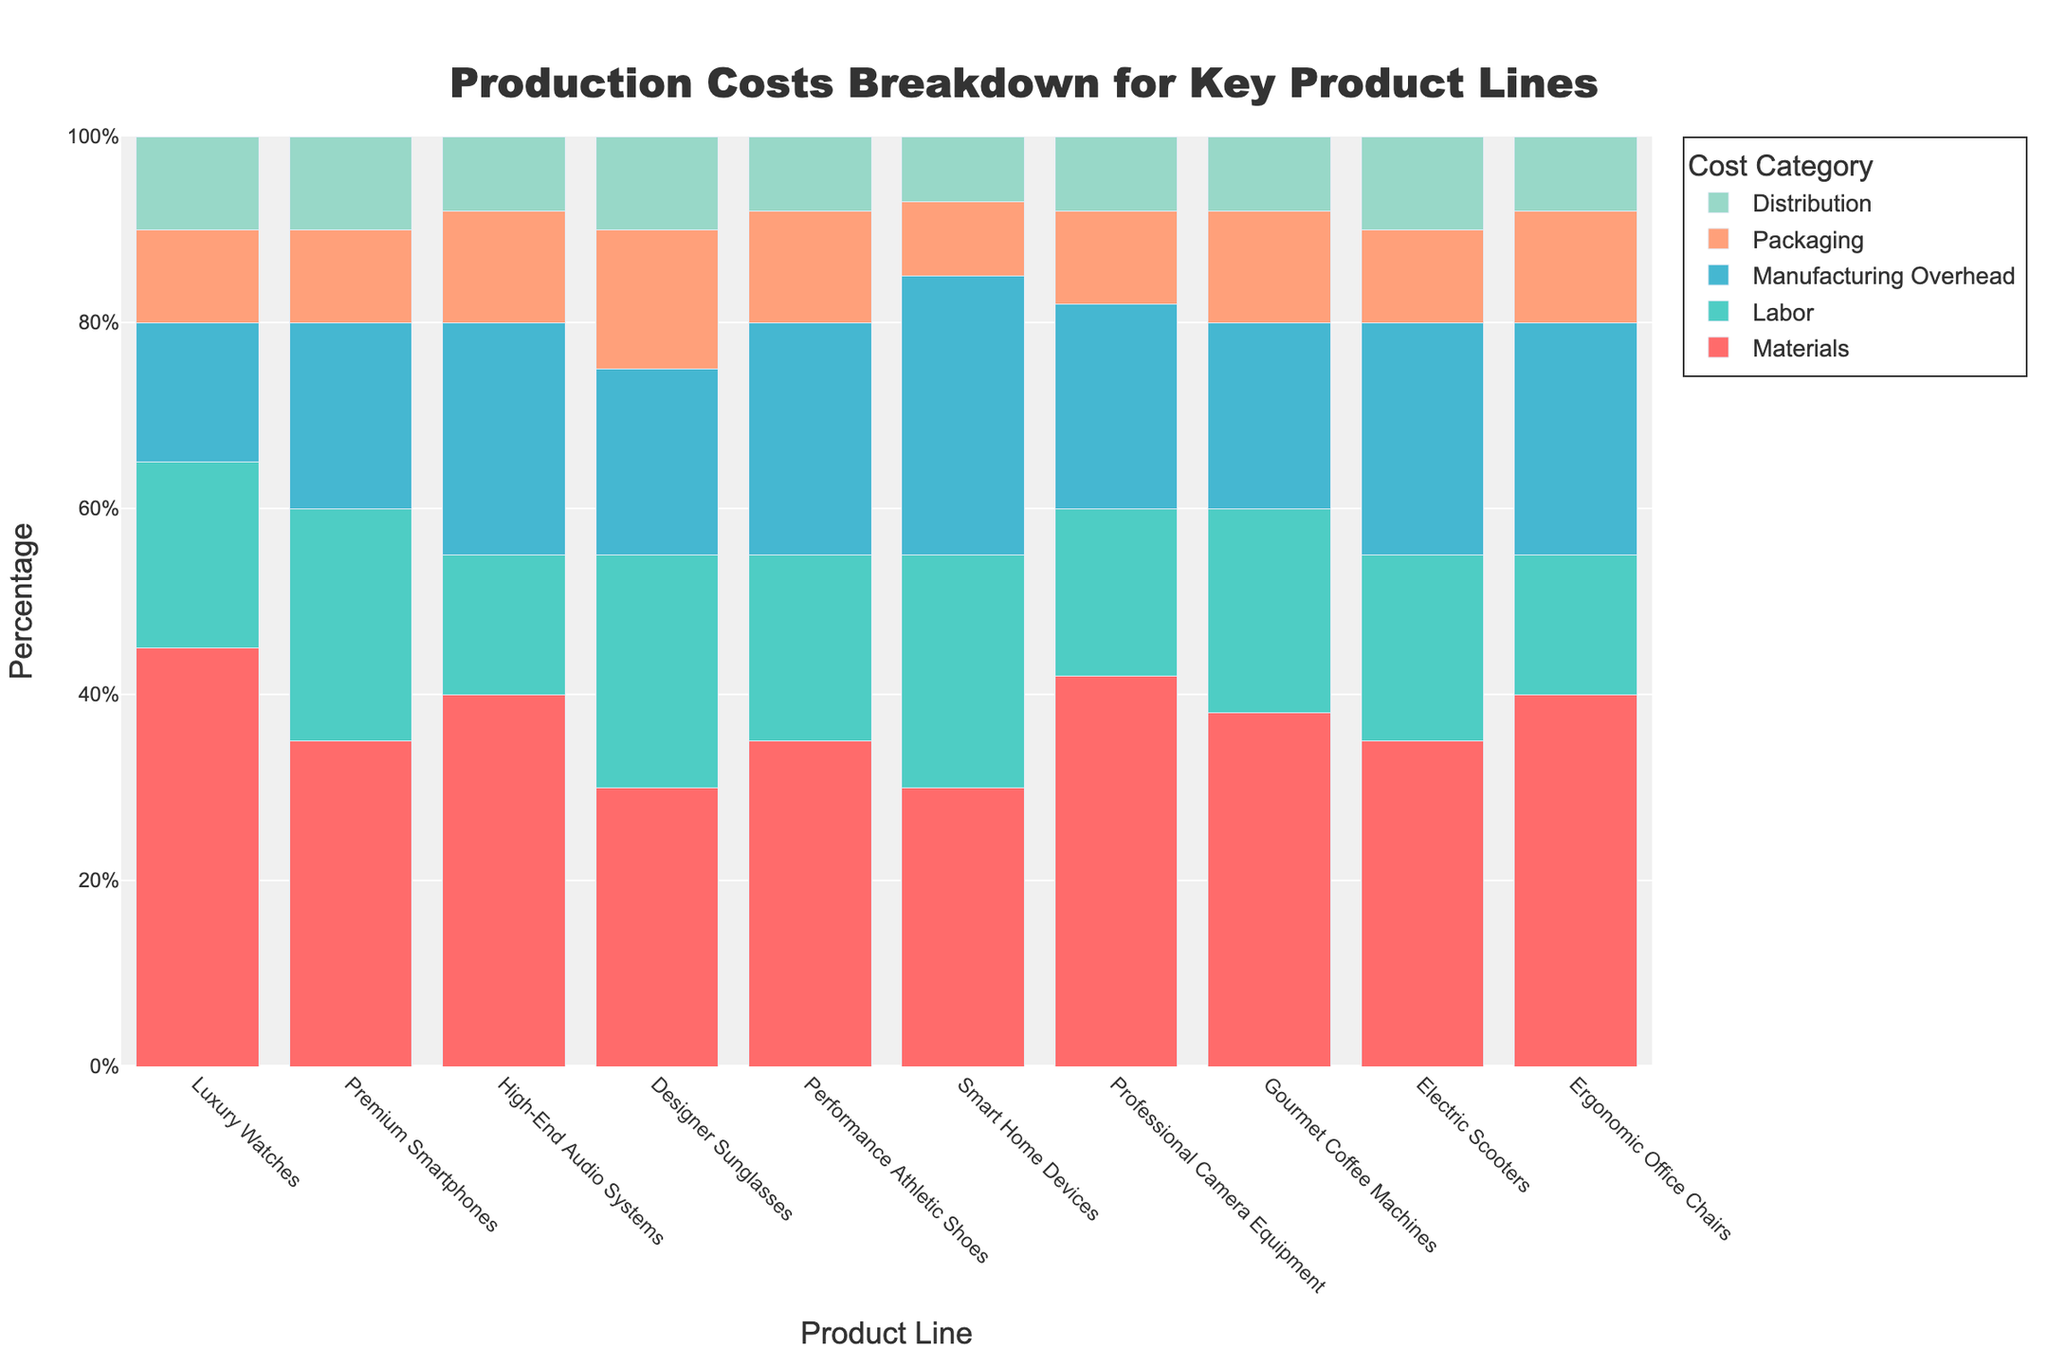Which product line has the highest percentage of materials cost? By checking the color representing the materials cost across all bars, the Luxury Watches bar appears to be the tallest.
Answer: Luxury Watches Which product line has the lowest percentage of distribution cost? By looking at the distribution sections (smallest segments) of each bar, the Smart Home Devices segment is shortest.
Answer: Smart Home Devices What is the total percentage of packaging and distribution for Premium Smartphones? Sum the packaging and distribution percentages for Premium Smartphones (10% + 10%).
Answer: 20% Compare the manufacturing overhead costs between High-End Audio Systems and Electric Scooters. Which is higher and by how much? High-End Audio Systems have 25% and Electric Scooters have 25% for manufacturing overhead, thus it's the same.
Answer: Equal, 0% For which product line is the sum of labor and packaging costs equal to 40%? The sum of labor and packaging in Designer Sunglasses (25% + 15%) equals 40%.
Answer: Designer Sunglasses What percentage of total costs do labor and manufacturing overhead comprise for Gourmet Coffee Machines? Sum labor and manufacturing overhead for Gourmet Coffee Machines (22% + 20%).
Answer: 42% Which product line has the highest percentage for manufacturing overhead? By comparing the manufacturing overhead sections in the bars, Smart Home Devices have the tallest section at 30%.
Answer: Smart Home Devices What is the difference in materials cost percentage between Professional Camera Equipment and Designer Sunglasses? Subtract the materials cost for Designer Sunglasses (30%) from Professional Camera Equipment (42%).
Answer: 12% Which cost category in Performance Athletic Shoes has the highest percentage? By observing the Performance Athletic Shoes bar, the manufacturing overhead (25%) is the highest.
Answer: Manufacturing Overhead 